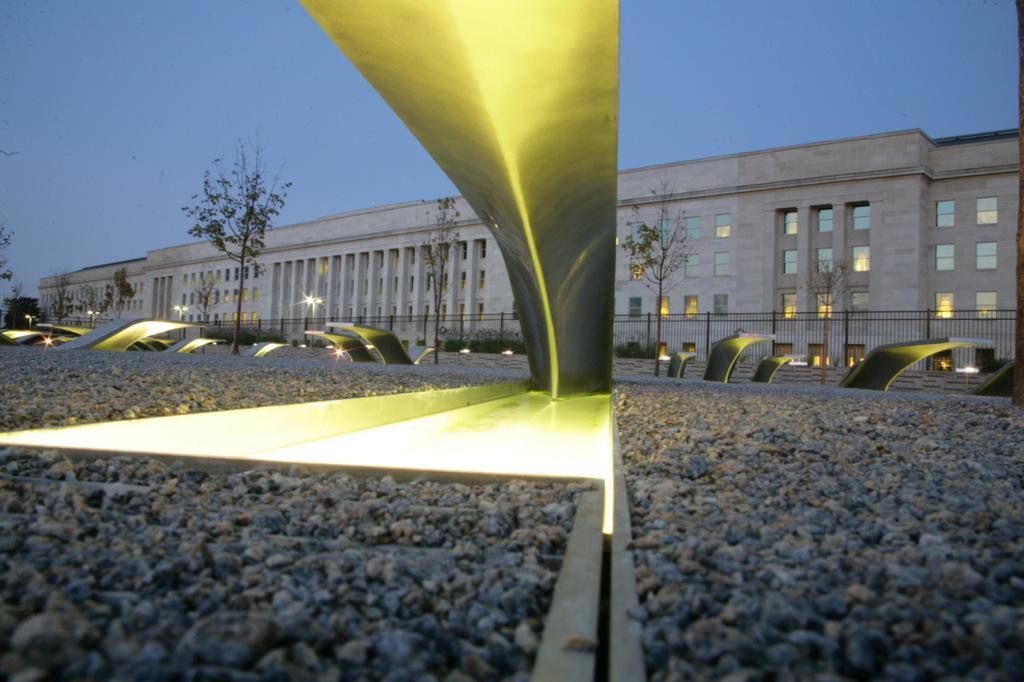What type of path is visible in the image? There is a path filled with stones in the image. Are there any decorations on the path? Yes, the path is decorated with lights. What can be seen alongside the path? Trees are present along the path. What is visible in the background of the image? There is a building with many windows in the background. How would you describe the sky in the image? The sky appears gloomy in the image. Can you tell me how many sticks of butter are placed on the path in the image? There is no butter present on the path in the image. Is there a girl walking along the path in the image? There is no girl visible in the image. 